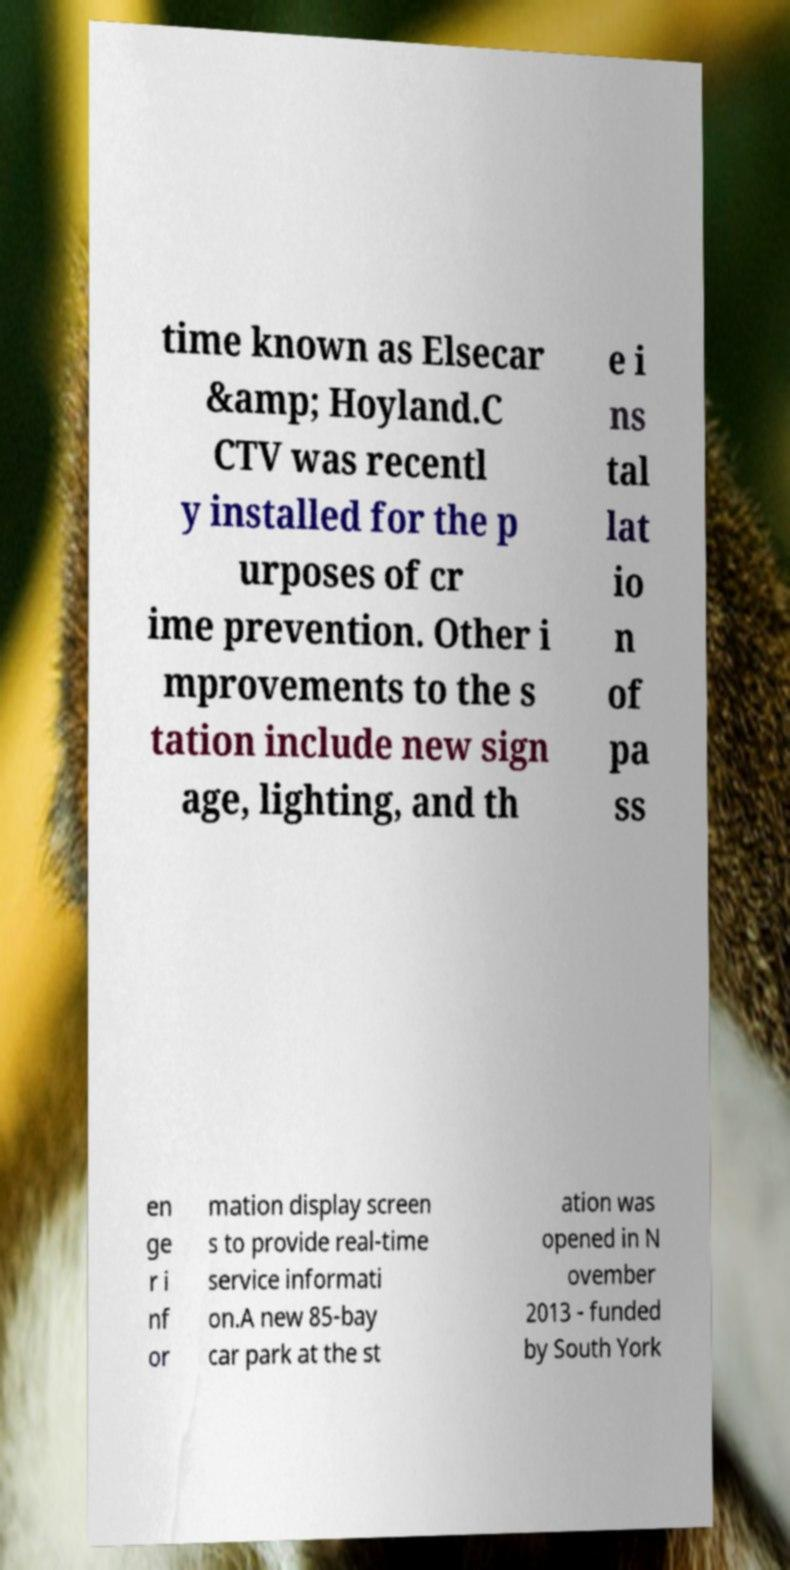There's text embedded in this image that I need extracted. Can you transcribe it verbatim? time known as Elsecar &amp; Hoyland.C CTV was recentl y installed for the p urposes of cr ime prevention. Other i mprovements to the s tation include new sign age, lighting, and th e i ns tal lat io n of pa ss en ge r i nf or mation display screen s to provide real-time service informati on.A new 85-bay car park at the st ation was opened in N ovember 2013 - funded by South York 